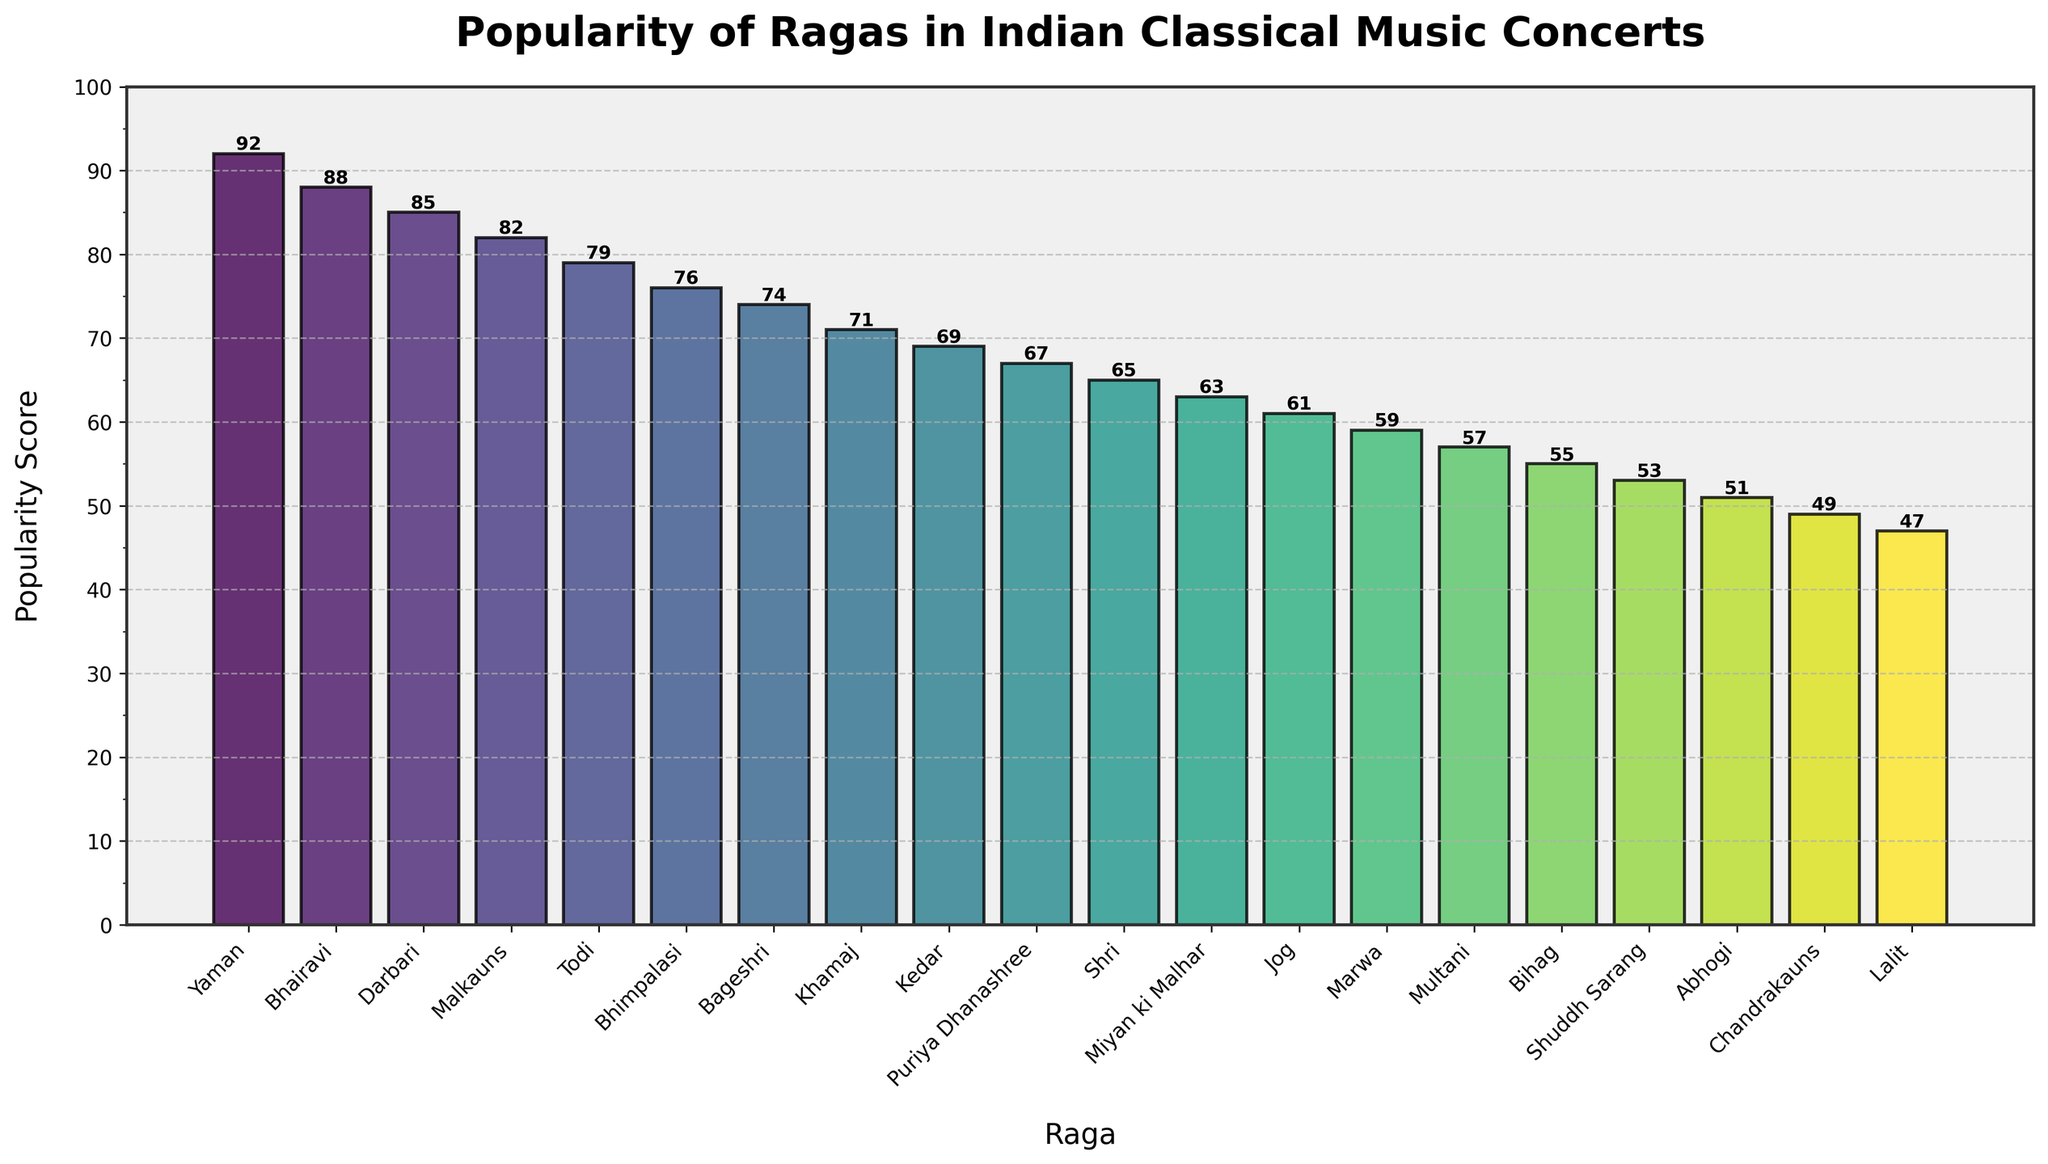What's the most popular raga according to the chart? The bar representing 'Yaman' is the tallest, indicating it has the highest popularity score of 92.
Answer: Yaman Which raga is less popular, 'Bhairavi' or 'Darbari'? By comparing the heights of the bars, 'Darbari' is slightly shorter than 'Bhairavi', with popularity scores of 85 and 88, respectively.
Answer: Darbari How much more popular is 'Yaman' than 'Miyan ki Malhar'? The popularity score of 'Yaman' is 92, and 'Miyan ki Malhar' is 63. The difference is 92 - 63.
Answer: 29 What is the average popularity score of the top 5 ragas? The top 5 ragas are 'Yaman', 'Bhairavi', 'Darbari', 'Malkauns', and 'Todi' with scores 92, 88, 85, 82, and 79. The average is (92 + 88 + 85 + 82 + 79) / 5.
Answer: 85.2 How many ragas have a popularity score greater than 75? By visually counting the ragas with scores above 75, we find 'Yaman', 'Bhairavi', 'Darbari', 'Malkauns', and 'Todi'.
Answer: 5 What's the difference in popularity score between the least and the most popular ragas? The least popular raga is 'Lalit' with a score of 47, the most popular raga is 'Yaman' with a score of 92. The difference is 92 - 47.
Answer: 45 Which ragas have a score within the range of 60 to 70? The ragas and their scores within this range are 'Khamaj' (71), 'Kedar' (69), 'Puriya Dhanashree' (67), 'Shri' (65), and 'Miyan ki Malhar' (63).
Answer: Khamaj, Kedar, Puriya Dhanashree, Shri, Miyan ki Malhar Are there any ragas with the same popularity score? By scanning the popularity scores, there are no two ragas with the same score.
Answer: No What is the median popularity score of all the ragas? With 20 ragas, the median will be the average of the 10th and 11th scores when sorted. These scores are 69 for 'Kedar' and 67 for 'Puriya Dhanashree'.
Answer: 68 